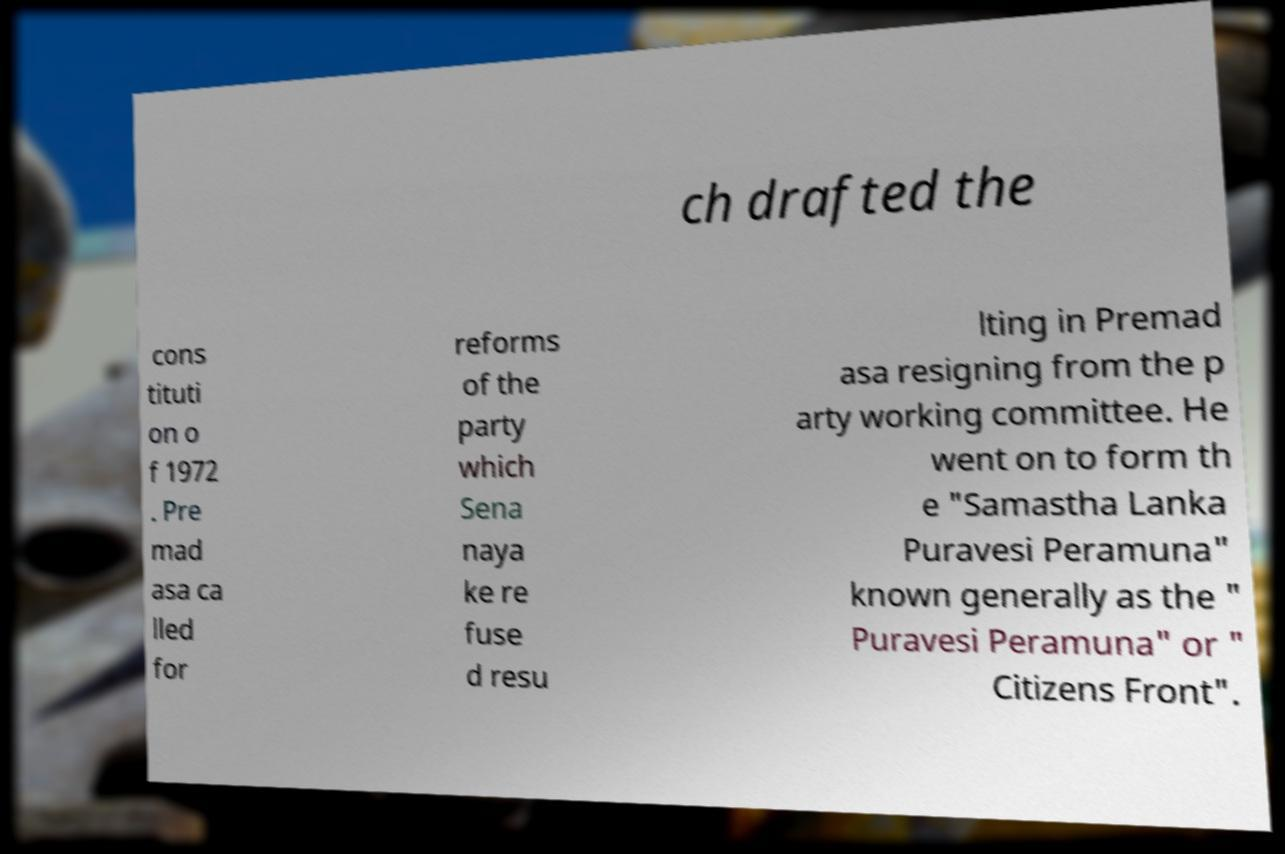Can you read and provide the text displayed in the image?This photo seems to have some interesting text. Can you extract and type it out for me? ch drafted the cons tituti on o f 1972 . Pre mad asa ca lled for reforms of the party which Sena naya ke re fuse d resu lting in Premad asa resigning from the p arty working committee. He went on to form th e "Samastha Lanka Puravesi Peramuna" known generally as the " Puravesi Peramuna" or " Citizens Front". 